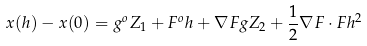Convert formula to latex. <formula><loc_0><loc_0><loc_500><loc_500>x ( h ) - x ( 0 ) = g ^ { o } Z _ { 1 } + F ^ { o } h + \nabla F g Z _ { 2 } + \frac { 1 } { 2 } \nabla F \cdot F h ^ { 2 }</formula> 